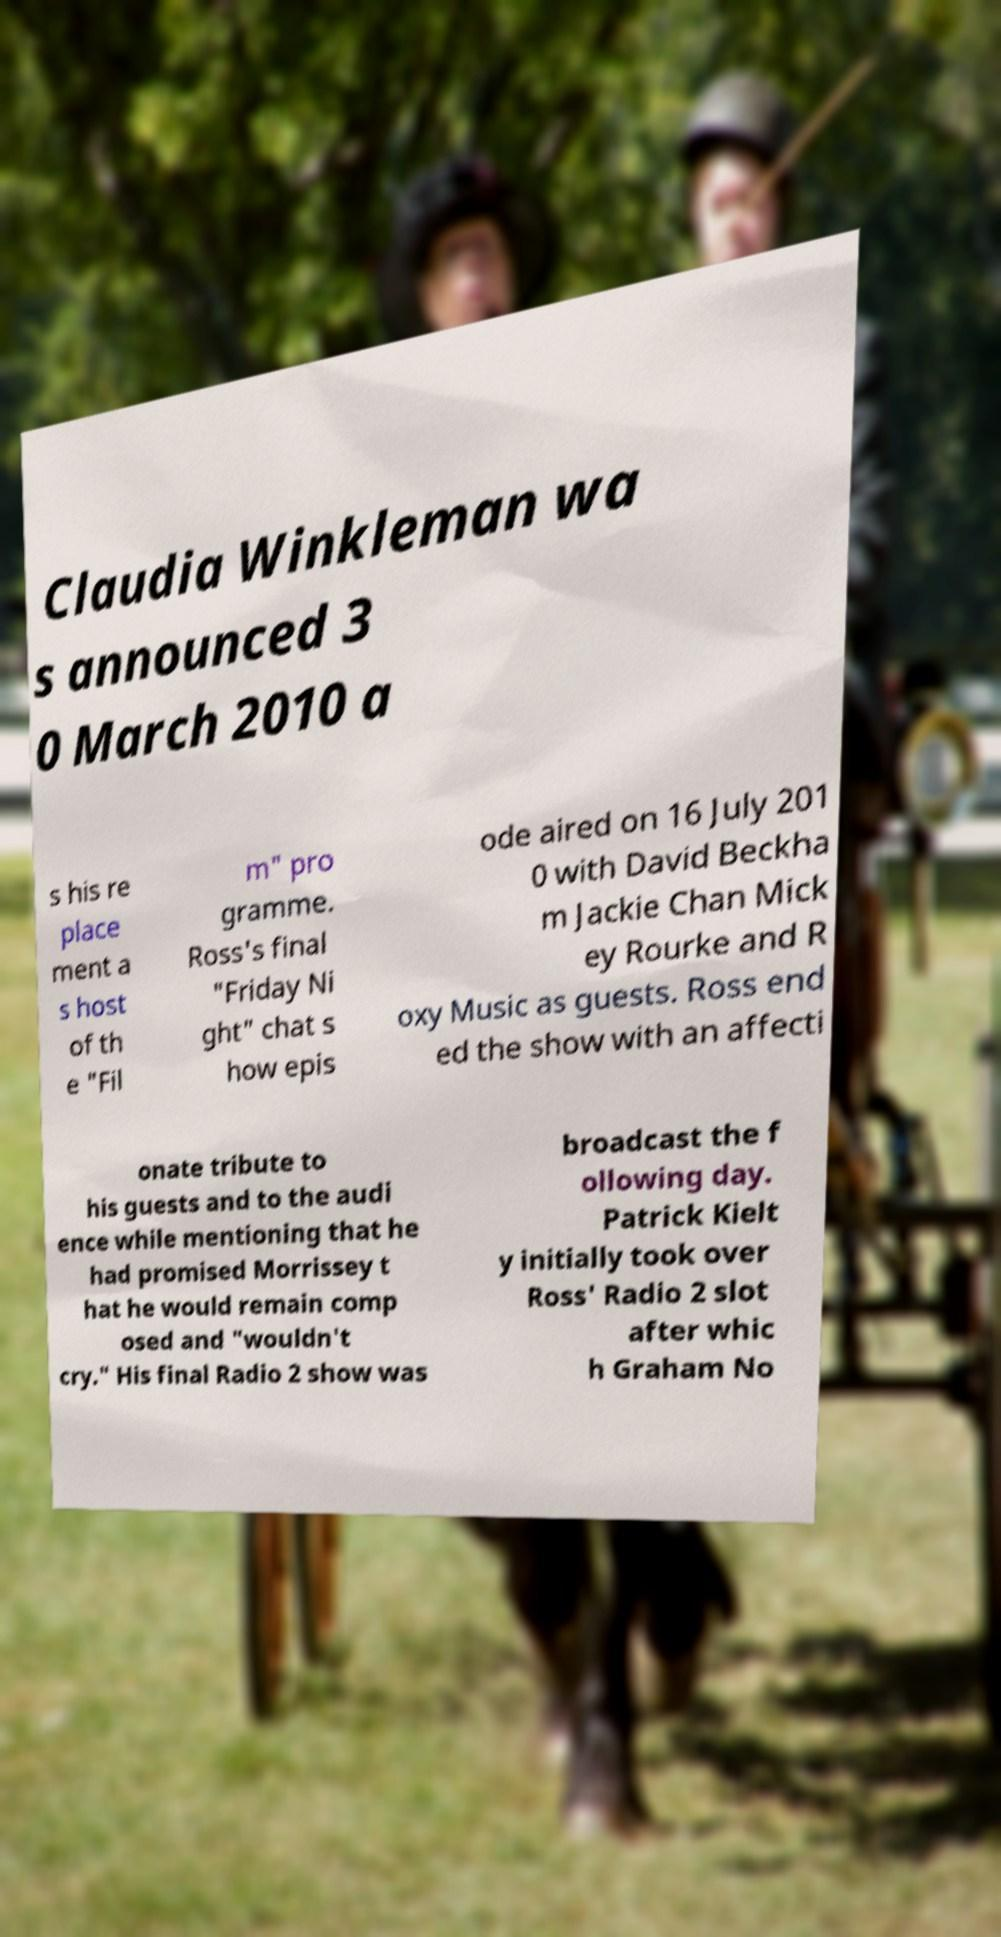Can you read and provide the text displayed in the image?This photo seems to have some interesting text. Can you extract and type it out for me? Claudia Winkleman wa s announced 3 0 March 2010 a s his re place ment a s host of th e "Fil m" pro gramme. Ross's final "Friday Ni ght" chat s how epis ode aired on 16 July 201 0 with David Beckha m Jackie Chan Mick ey Rourke and R oxy Music as guests. Ross end ed the show with an affecti onate tribute to his guests and to the audi ence while mentioning that he had promised Morrissey t hat he would remain comp osed and "wouldn't cry." His final Radio 2 show was broadcast the f ollowing day. Patrick Kielt y initially took over Ross' Radio 2 slot after whic h Graham No 